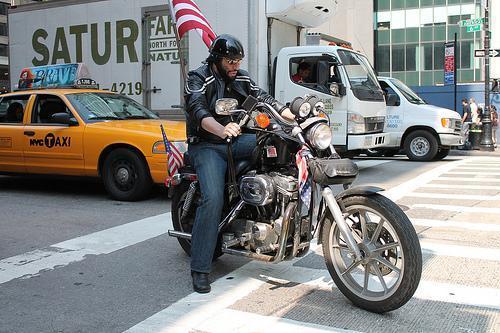How many motorcycles are visible?
Give a very brief answer. 1. 